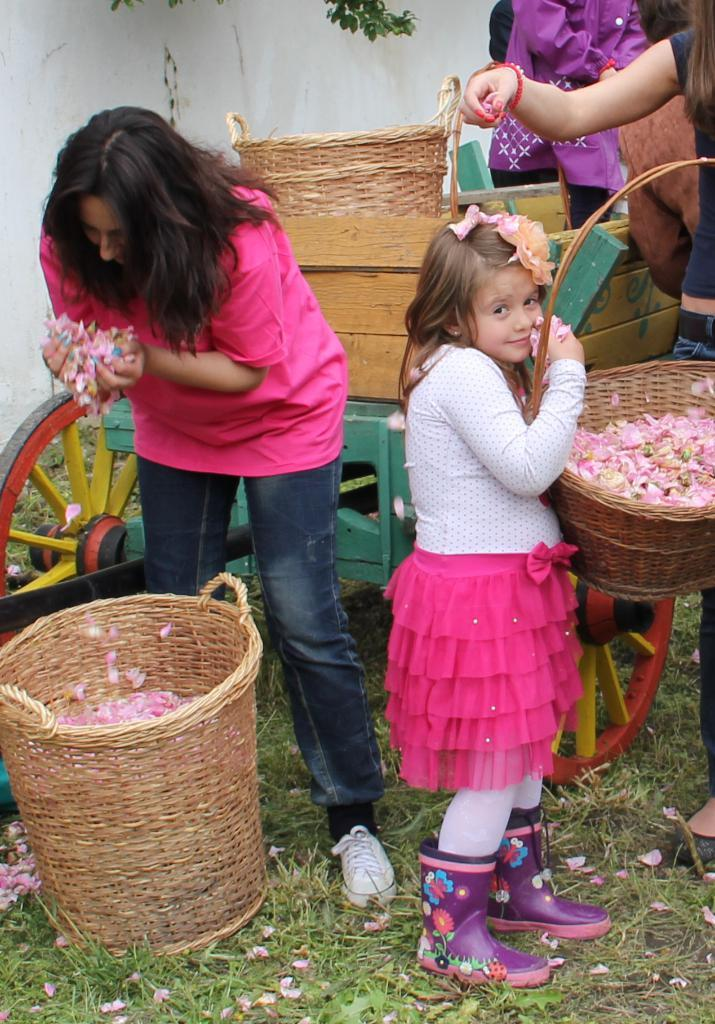Who is the main subject in the image? There is a woman in the image. What is the woman wearing? The woman is wearing a pink top. What else can be seen in the image? There is a cart in the image. Who else is present in the image? There is a cute girl in the image. What is the girl holding in her hands? The girl is holding a basket in her hands. What type of structure is the woman leaning against in the image? There is no structure present in the image for the woman to lean against. 